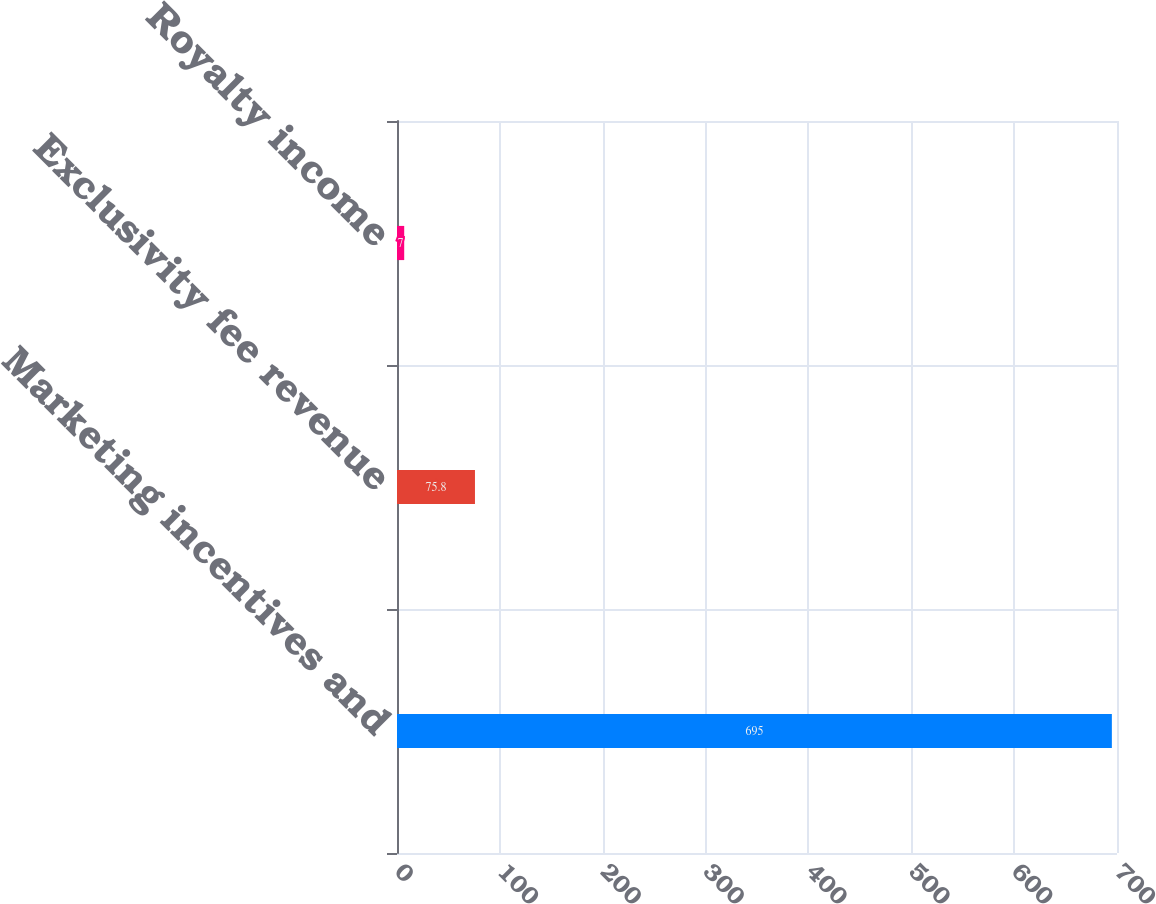<chart> <loc_0><loc_0><loc_500><loc_500><bar_chart><fcel>Marketing incentives and<fcel>Exclusivity fee revenue<fcel>Royalty income<nl><fcel>695<fcel>75.8<fcel>7<nl></chart> 